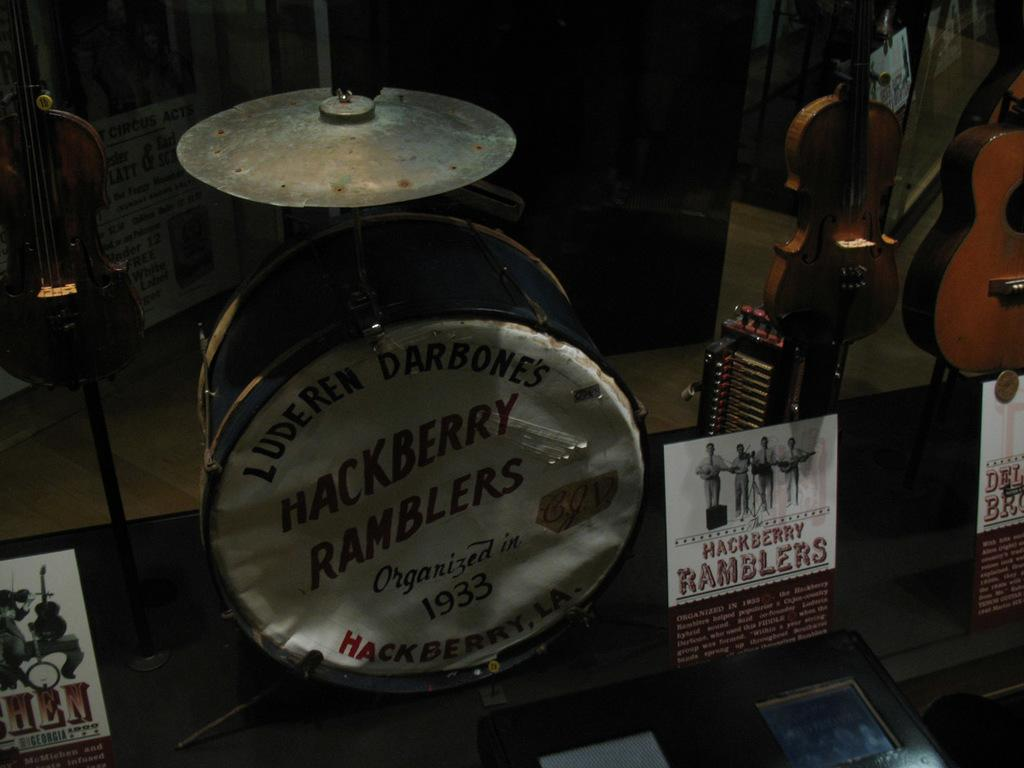What is the main object in the image? There is a table in the image. What is placed on the table? There are musical instruments on the table. Is there any additional information on the table? Yes, there is a pamphlet stuck on the table. What can be seen behind the table? There is a big wall visible behind the table. Can you see any snakes slithering on the table in the image? No, there are no snakes present in the image. Are there any grapes on the table in the image? No, there are no grapes visible in the image. 